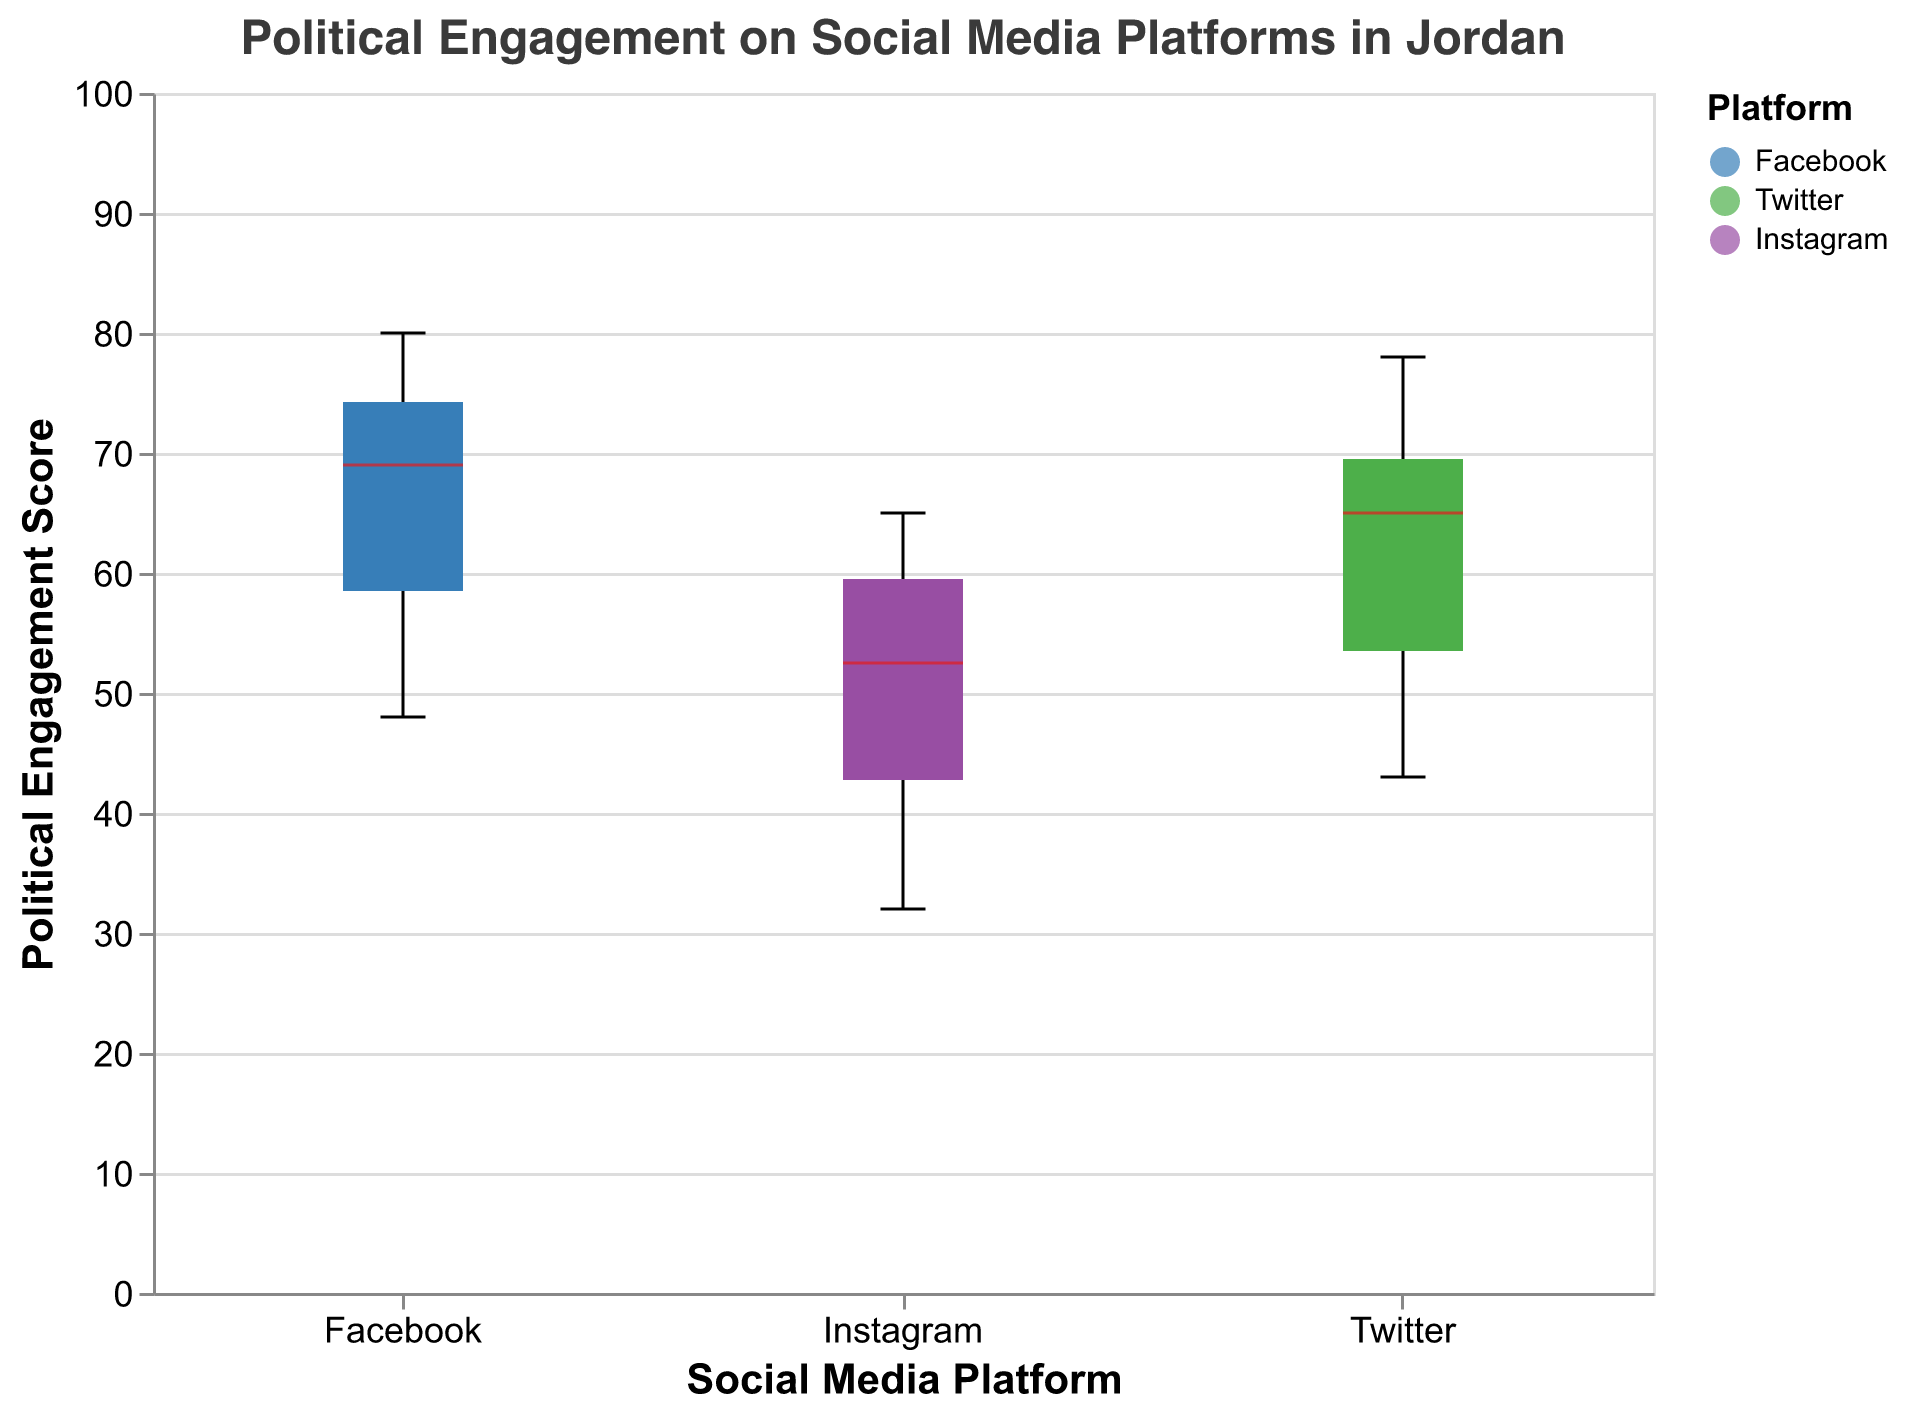What is the median political engagement score for Facebook users? The median is indicated by the horizontal line within the box. Referring to the Facebook notched box, the line is around 60-65.
Answer: 63 Which age group shows the highest political engagement on Twitter? By comparing the scores across the age groups on the Twitter plot, the 25-34 age group has scores around 70-78, higher than other age groups.
Answer: 25-34 Are males or females more politically engaged on Instagram in the 35-44 age group? Examine the Instagram box plots for the 35-44 age group. Scores for males cluster higher than those for females.
Answer: Males How does the political engagement on Facebook compare with Twitter for the 18-24 age group? Comparing the Facebook and Twitter notched box plots for 18-24, Facebook scores are generally higher.
Answer: Facebook has higher scores What is the notched region indicating for Instagram users in the 55-64 age group? The notch reveals the confidence interval around the median. Referring to the Instagram plot for 55-64, the notch is around 30-40.
Answer: 30-40 What trend is observed in political engagement as age increases on all platforms? Observing all box plots, there is a general decrease in political engagement scores as age increases.
Answer: Engagement decreases with age Which social media platform shows the widest range of political engagement scores? The boxplot with the largest vertical spread (range from min to max) across all data points is Facebook.
Answer: Facebook What is the median political engagement score for Instagram users across all age groups? By examining the horizontal lines within the Instagram notched boxes, the median is around 45-50.
Answer: 48 Is there a significant variation in political engagement scores for Twitter users between age groups? By comparing the notched regions, the variation appears significant as there is noticeable difference between age groups.
Answer: Yes Comparing across gender, which gender has higher political engagement scores on average for the 25-34 age group on Facebook? Comparing the male and female boxes for 25-34 on Facebook, the median scores for males are slightly higher.
Answer: Males 